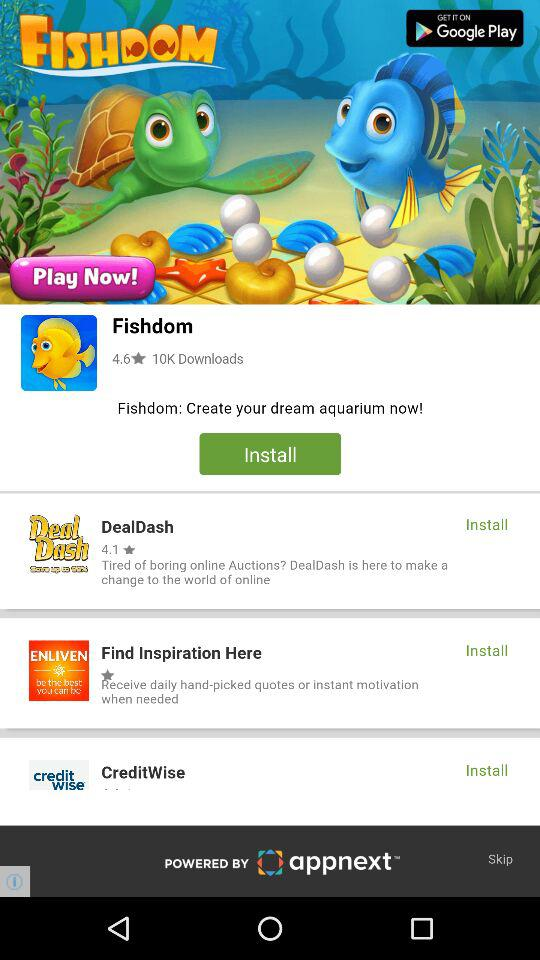What is the number of downloads done for "Fishdom"? The number of downloads is 10K. 